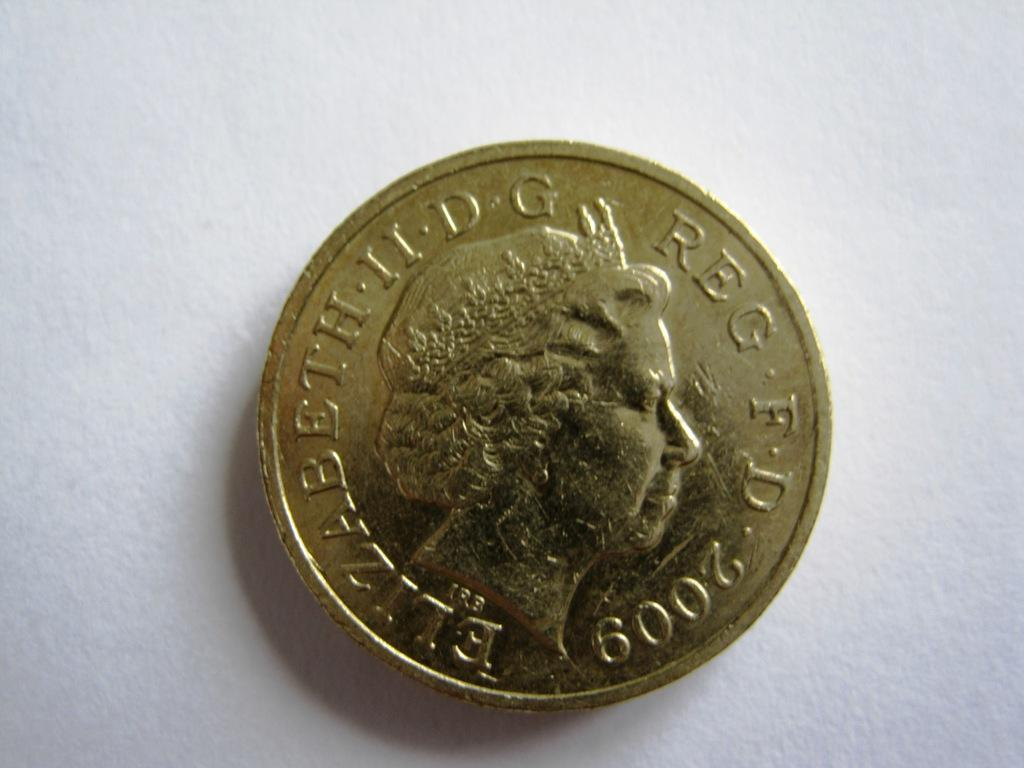<image>
Relay a brief, clear account of the picture shown. The coin of Queen Elizabeth shown was made in 2009. 